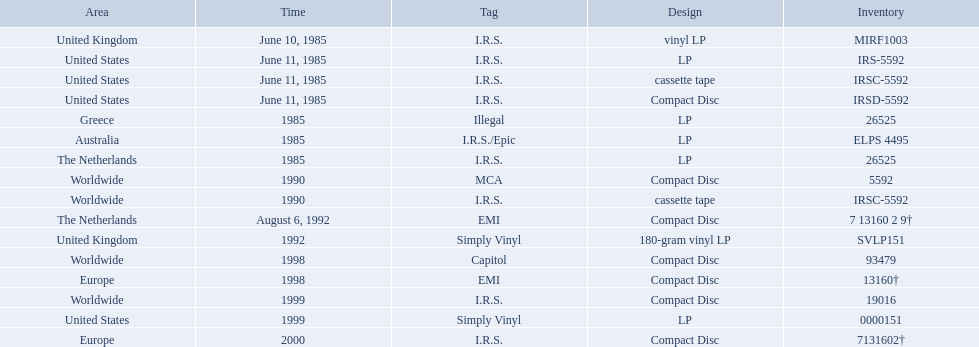In which regions was the fables of the reconstruction album released? United Kingdom, United States, United States, United States, Greece, Australia, The Netherlands, Worldwide, Worldwide, The Netherlands, United Kingdom, Worldwide, Europe, Worldwide, United States, Europe. And what were the release dates for those regions? June 10, 1985, June 11, 1985, June 11, 1985, June 11, 1985, 1985, 1985, 1985, 1990, 1990, August 6, 1992, 1992, 1998, 1998, 1999, 1999, 2000. And which region was listed after greece in 1985? Australia. Which dates were their releases by fables of the reconstruction? June 10, 1985, June 11, 1985, June 11, 1985, June 11, 1985, 1985, 1985, 1985, 1990, 1990, August 6, 1992, 1992, 1998, 1998, 1999, 1999, 2000. Which of these are in 1985? June 10, 1985, June 11, 1985, June 11, 1985, June 11, 1985, 1985, 1985, 1985. What regions were there releases on these dates? United Kingdom, United States, United States, United States, Greece, Australia, The Netherlands. Which of these are not greece? United Kingdom, United States, United States, United States, Australia, The Netherlands. Which of these regions have two labels listed? Australia. 